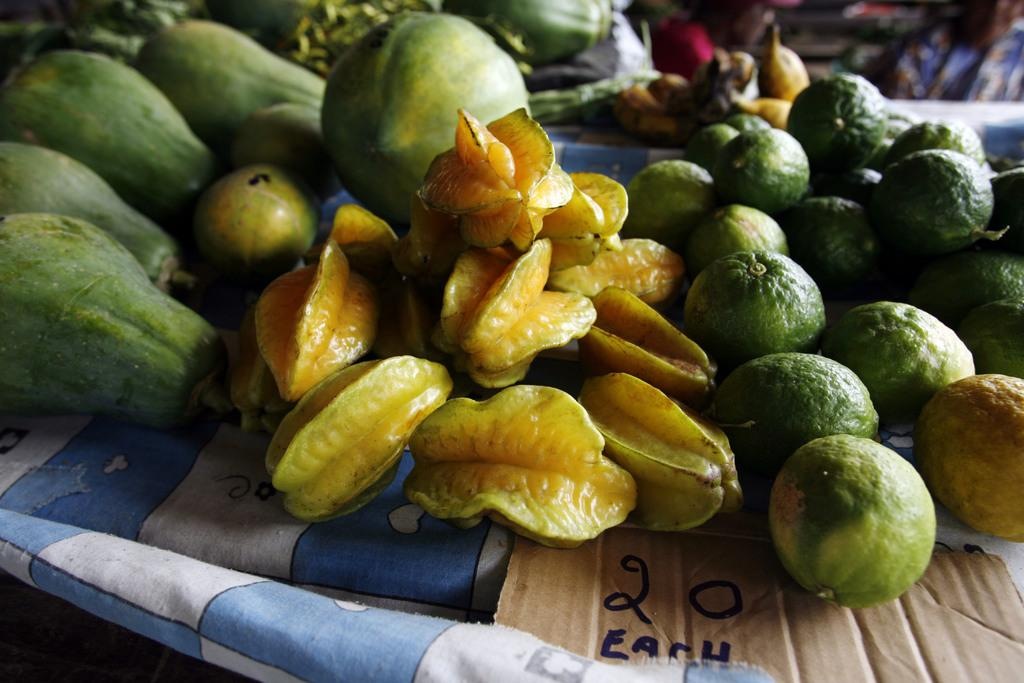What is placed on the blue cloth in the image? There are fruits on a blue cloth in the image. What else can be seen in the image besides the fruits? There is a cardboard with text and numbers in the image. Can you describe the people in the background of the image? There are a few people in the background of the image, but their features are not clear due to the blurry background. How would you describe the background of the image? The background is blurry. What type of haircut is the person in the image getting? There is no person getting a haircut in the image; it features fruits on a blue cloth and a cardboard with text and numbers. What ingredients are used to make the stew in the image? There is no stew present in the image; it features fruits on a blue cloth and a cardboard with text and numbers. 